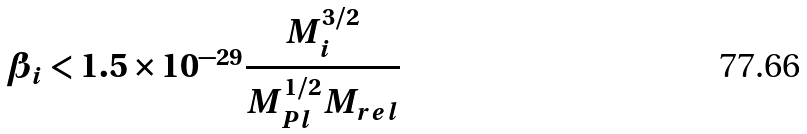<formula> <loc_0><loc_0><loc_500><loc_500>\beta _ { i } < 1 . 5 \times 1 0 ^ { - 2 9 } \frac { M _ { i } ^ { 3 / 2 } } { M _ { P l } ^ { 1 / 2 } M _ { r e l } }</formula> 